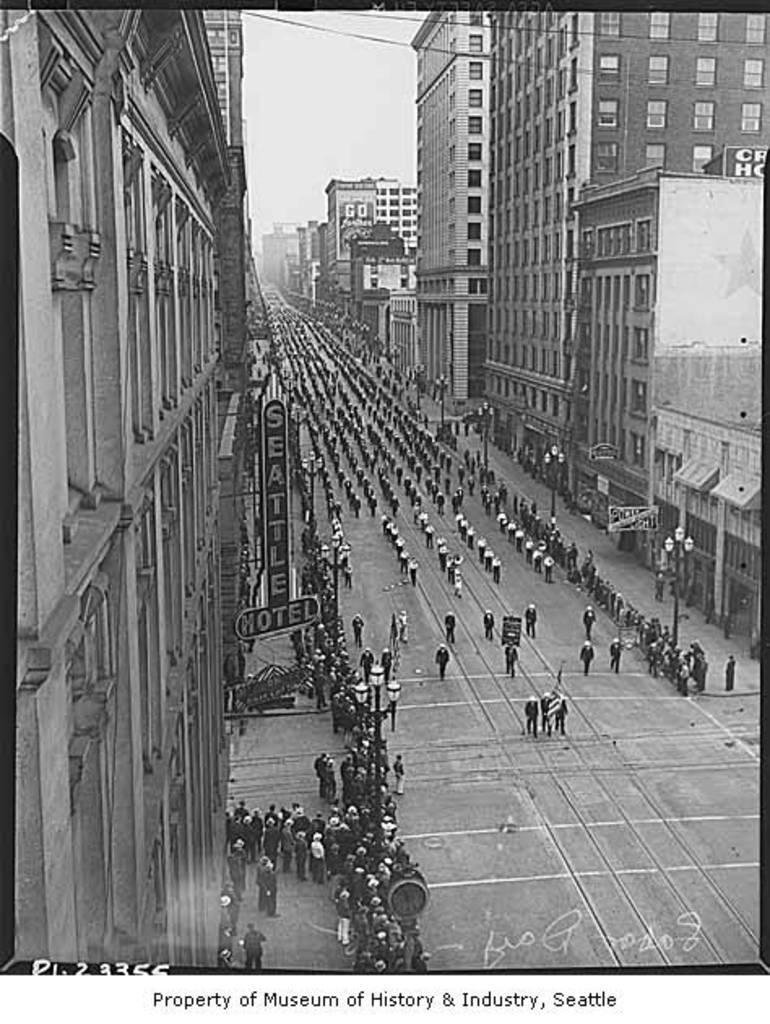What is the color scheme of the image? The image is black and white. What are the people in the image doing? The people in the image are walking. Where are the people walking? The people are walking on a road. What can be seen on either side of the road? There are buildings on either side of the road. Can you tell me how many snails are crawling on the road in the image? There are no snails present in the image; it only shows people walking on the road. What type of cat can be seen interacting with the people walking in the image? There is no cat present in the image; it only features people walking on the road and buildings on either side. 